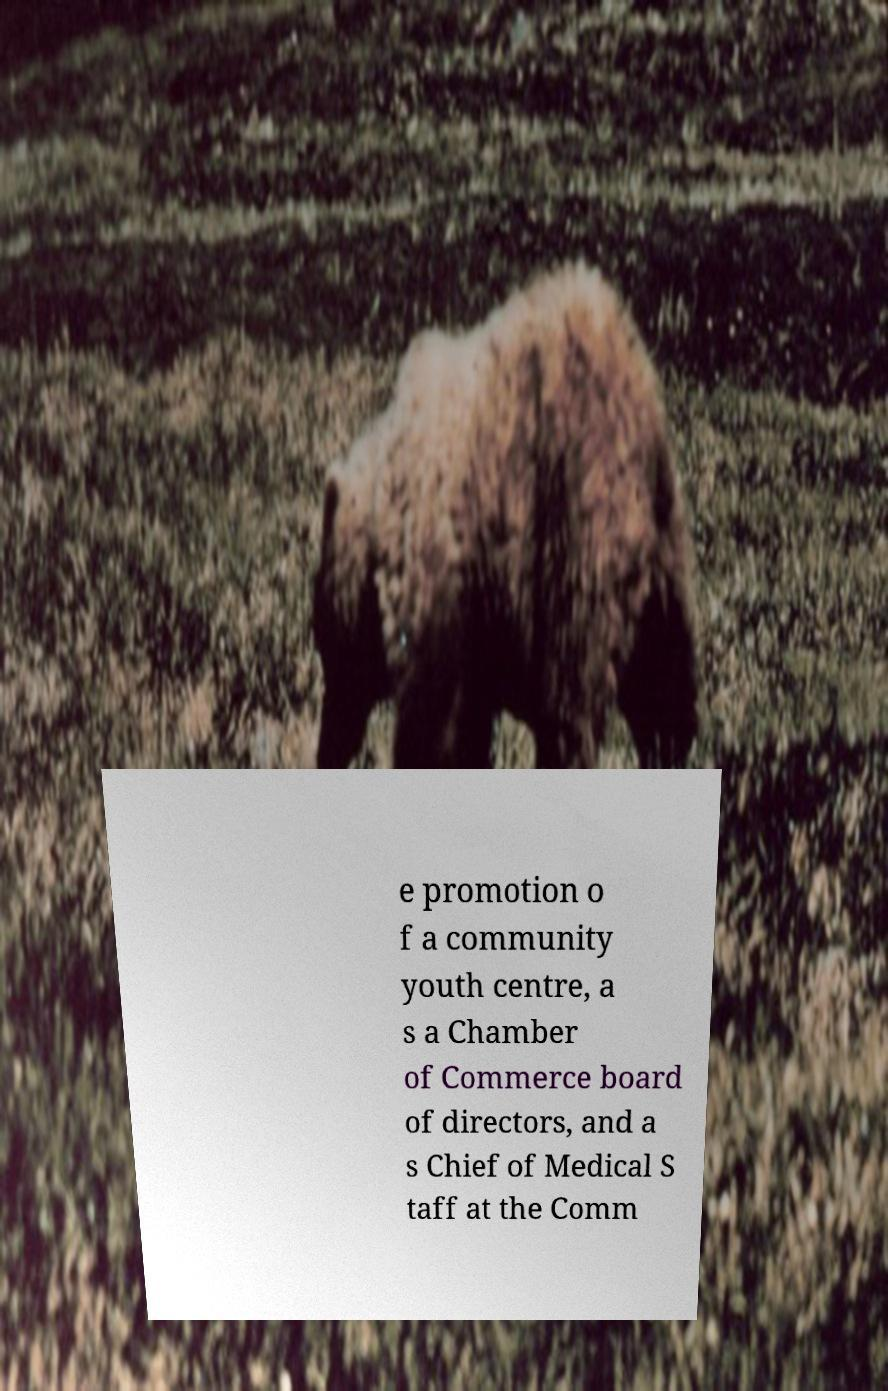Can you accurately transcribe the text from the provided image for me? e promotion o f a community youth centre, a s a Chamber of Commerce board of directors, and a s Chief of Medical S taff at the Comm 